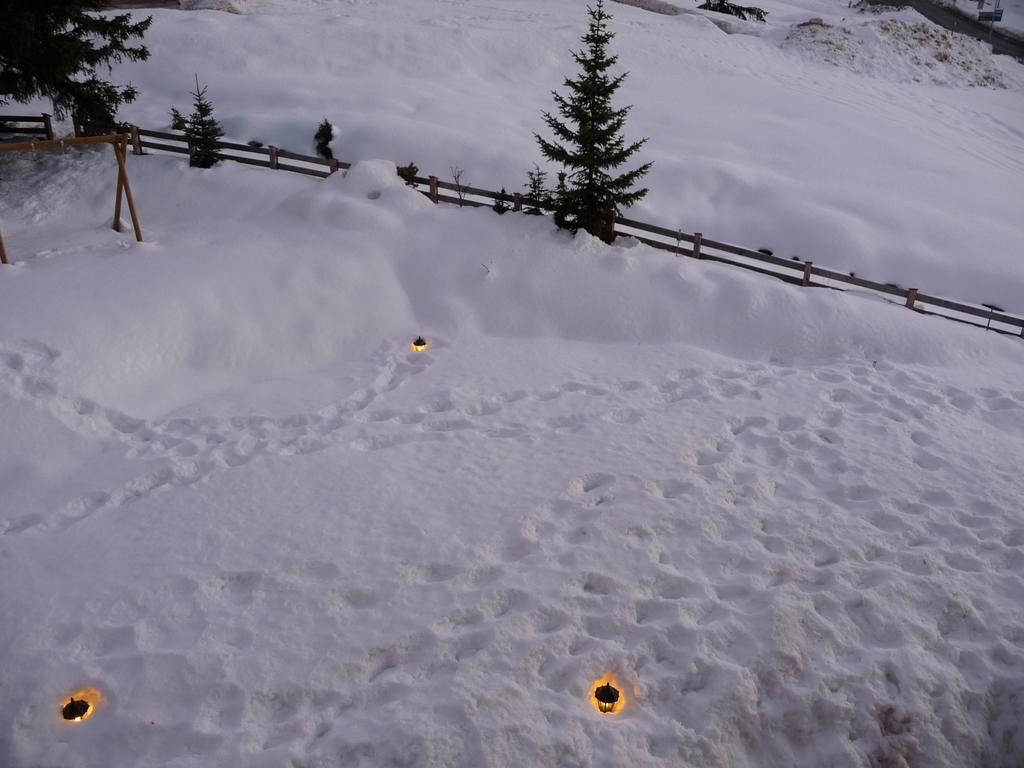What is the condition of the ground in the image? The ground in the image is covered with snow. What can be seen in the background of the image? There are trees visible in the background of the image. What type of fencing is present in the image? There is a wooden fencing in the image. How many roses can be seen growing on the wooden fencing in the image? There are no roses visible on the wooden fencing in the image. What type of rail is present in the image? There is no rail present in the image. 